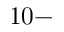<formula> <loc_0><loc_0><loc_500><loc_500>1 0 -</formula> 